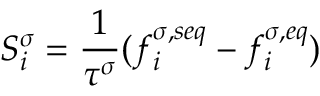<formula> <loc_0><loc_0><loc_500><loc_500>S _ { i } ^ { \sigma } = \frac { 1 } { \tau ^ { \sigma } } ( f _ { i } ^ { \sigma , s e q } - f _ { i } ^ { \sigma , e q } )</formula> 